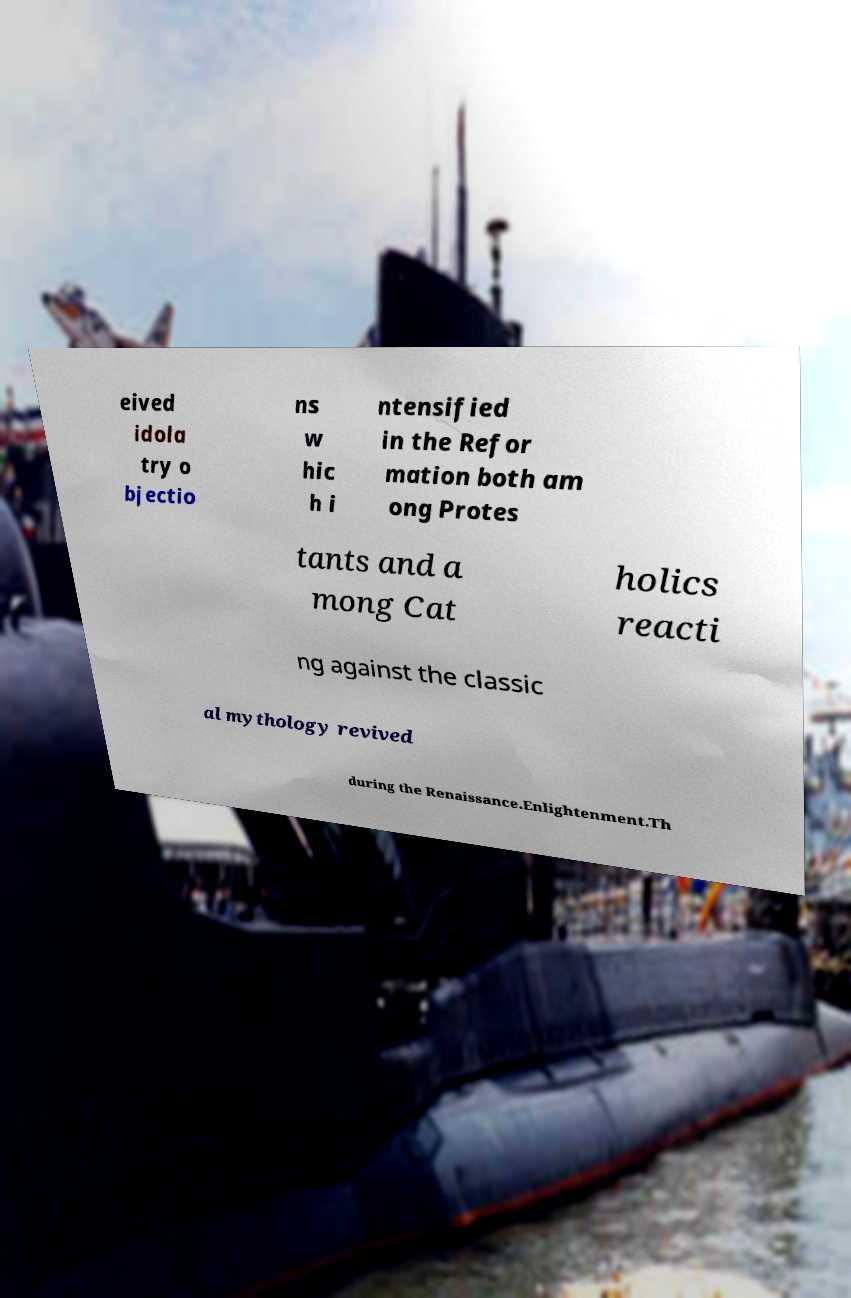Could you extract and type out the text from this image? eived idola try o bjectio ns w hic h i ntensified in the Refor mation both am ong Protes tants and a mong Cat holics reacti ng against the classic al mythology revived during the Renaissance.Enlightenment.Th 